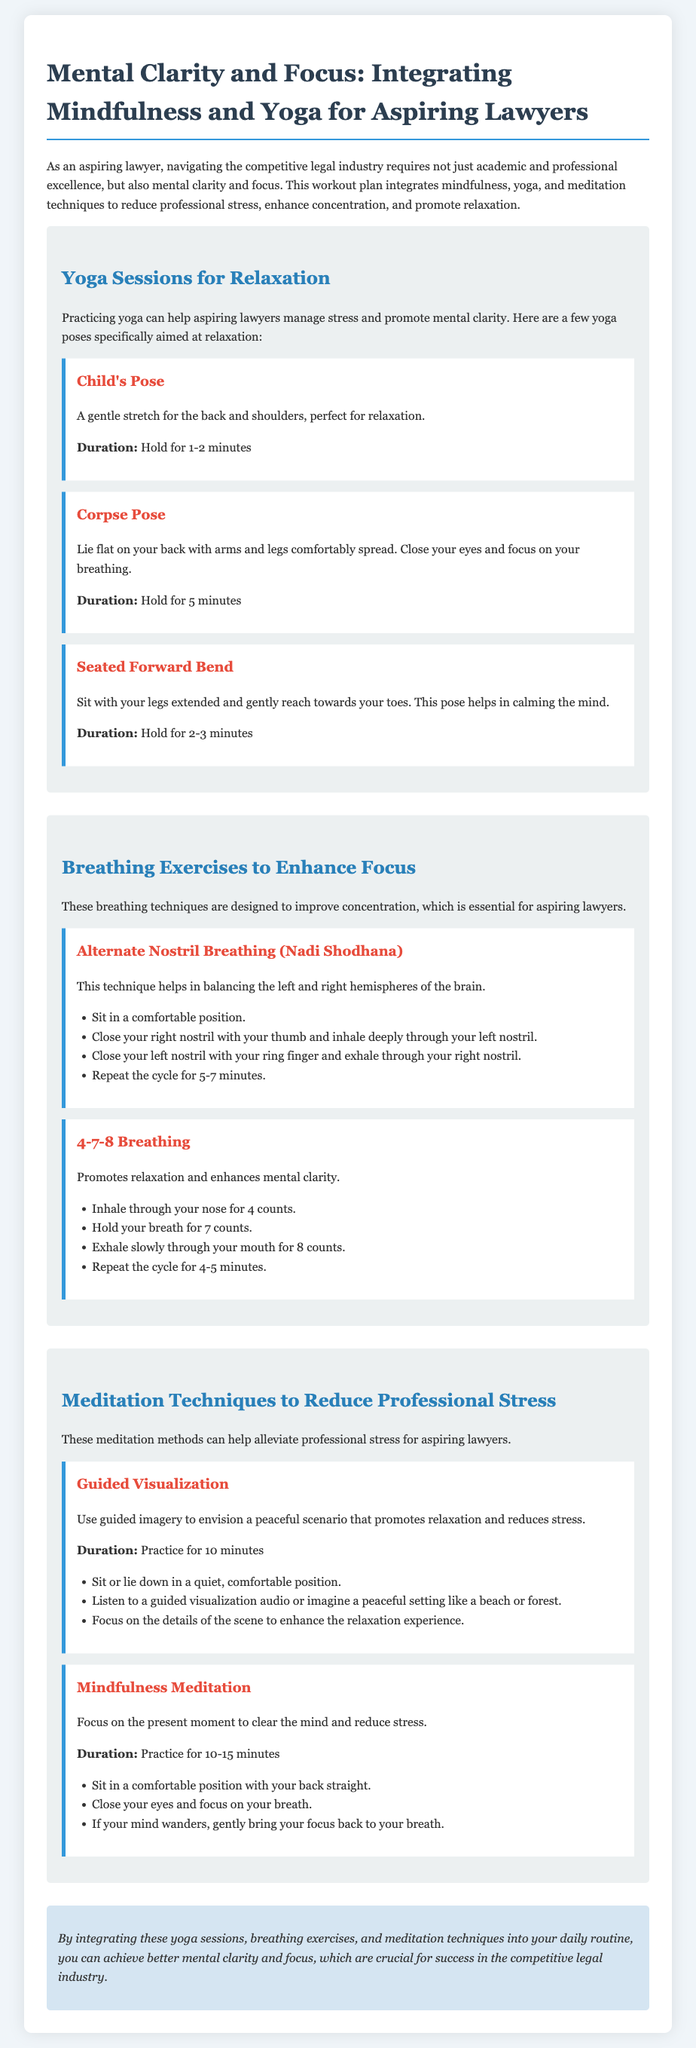What is the title of the document? The title of the document is the main heading presented at the top, describing the main theme of the content.
Answer: Mental Clarity and Focus: Integrating Mindfulness and Yoga for Aspiring Lawyers How long should Child's Pose be held? The document specifies the duration for each yoga pose, and Child's Pose is mentioned in that section.
Answer: Hold for 1-2 minutes What technique is used to balance the brain hemispheres? This document includes various breathing exercises, and one specifically mentioned for balancing the brain is detailed.
Answer: Alternate Nostril Breathing (Nadi Shodhana) How long should Guided Visualization be practiced? The duration for each meditation technique is included in the document, highlighting the time dedicated to each practice.
Answer: Practice for 10 minutes What is the main purpose of integrating these techniques? The document concludes with a summary of the benefits that come from practicing the techniques outlined.
Answer: Achieve better mental clarity and focus In which section is the 4-7-8 Breathing technique mentioned? The organization of the document is defined by sections, with each technique categorized accordingly.
Answer: Breathing Exercises to Enhance Focus What yoga pose is described as lying flat on your back? The descriptions of yoga poses in the relaxation section help the reader identify each pose by its characteristics.
Answer: Corpse Pose What is the duration for Mindfulness Meditation? The specified duration is indicated in the meditation techniques section, providing a clear time frame for practice.
Answer: 10-15 minutes 